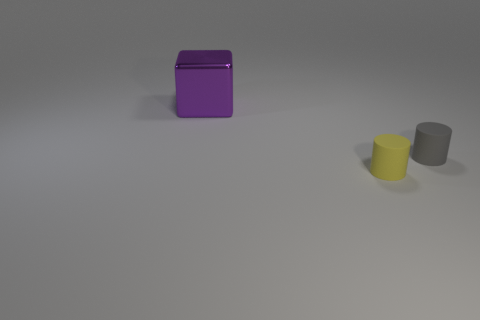Subtract 1 blocks. How many blocks are left? 0 Add 3 big cubes. How many objects exist? 6 Subtract all gray cylinders. How many cylinders are left? 1 Add 1 tiny cylinders. How many tiny cylinders exist? 3 Subtract 0 yellow balls. How many objects are left? 3 Subtract all cylinders. How many objects are left? 1 Subtract all yellow cylinders. Subtract all green balls. How many cylinders are left? 1 Subtract all green cubes. How many yellow cylinders are left? 1 Subtract all small gray rubber cylinders. Subtract all tiny yellow things. How many objects are left? 1 Add 2 blocks. How many blocks are left? 3 